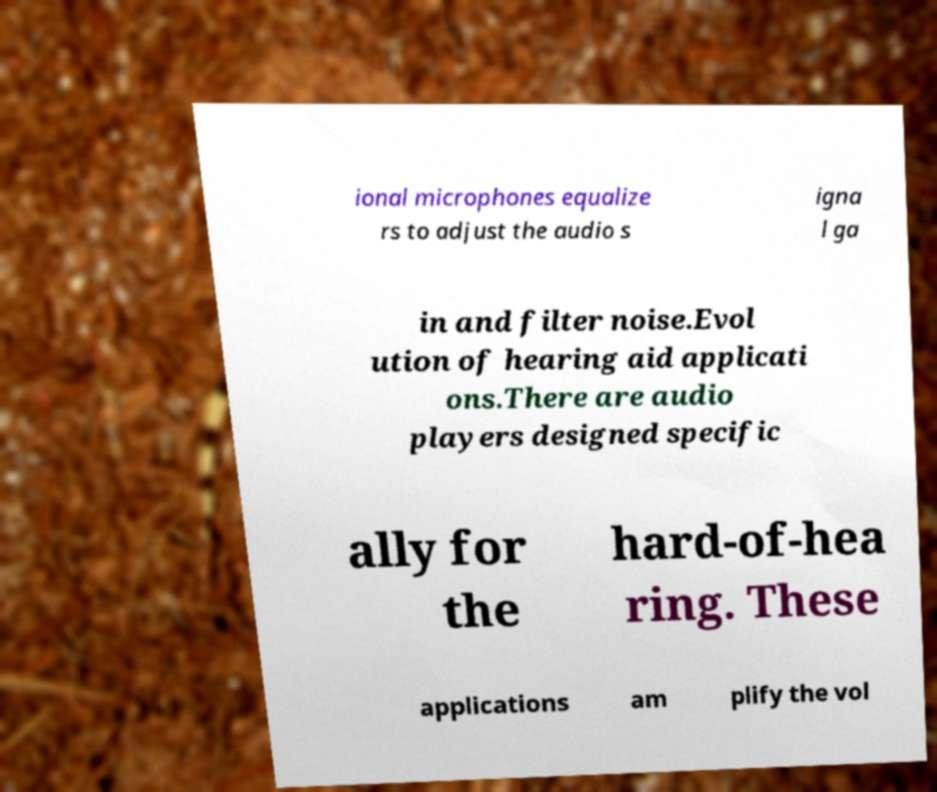For documentation purposes, I need the text within this image transcribed. Could you provide that? ional microphones equalize rs to adjust the audio s igna l ga in and filter noise.Evol ution of hearing aid applicati ons.There are audio players designed specific ally for the hard-of-hea ring. These applications am plify the vol 